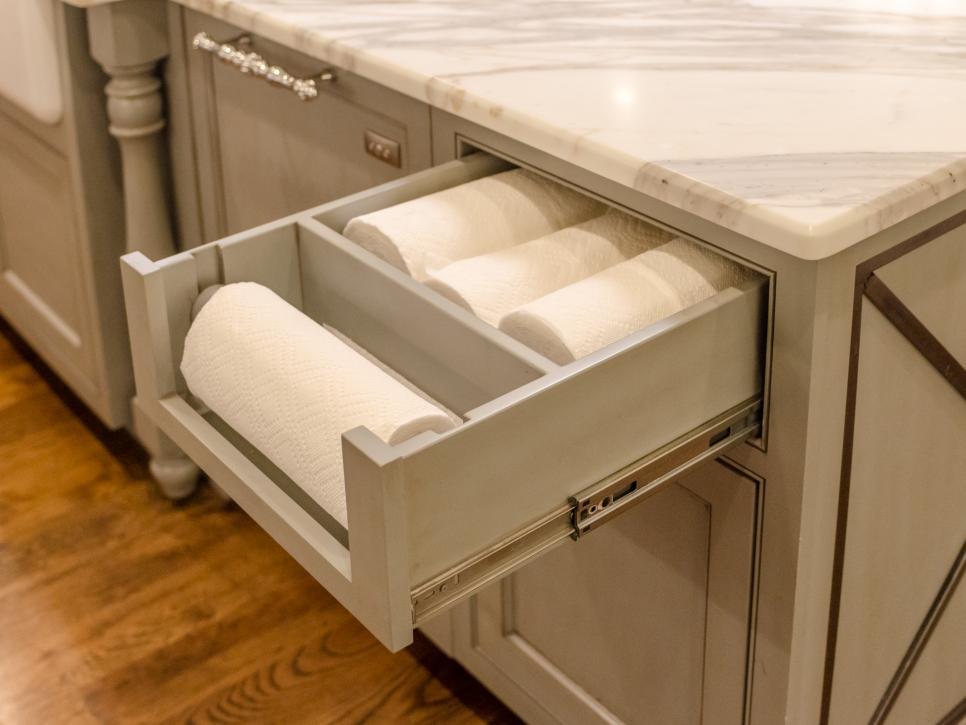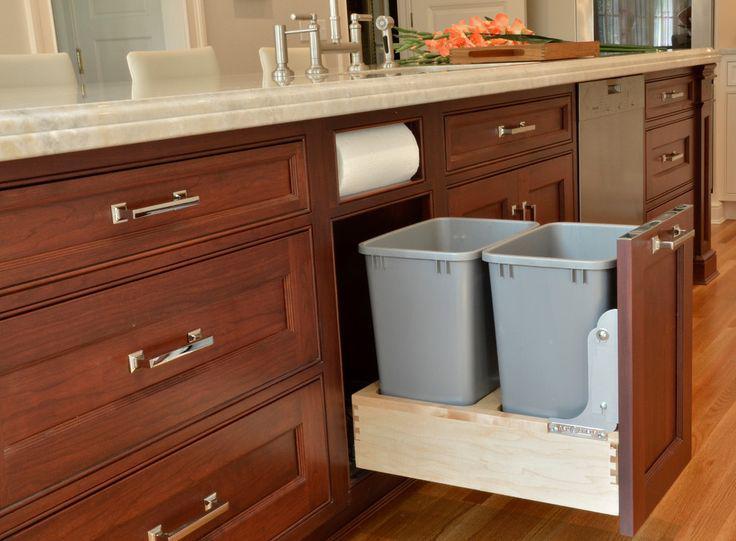The first image is the image on the left, the second image is the image on the right. Assess this claim about the two images: "The left image contains no more than one paper towel roll.". Correct or not? Answer yes or no. No. 